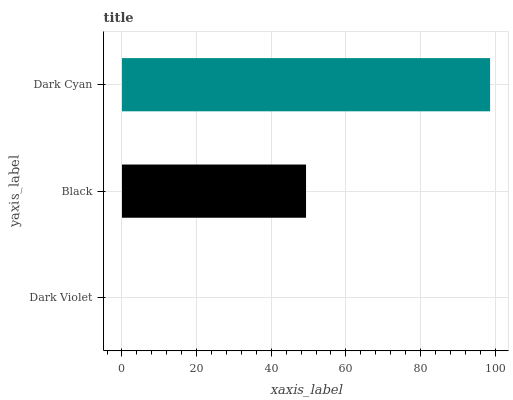Is Dark Violet the minimum?
Answer yes or no. Yes. Is Dark Cyan the maximum?
Answer yes or no. Yes. Is Black the minimum?
Answer yes or no. No. Is Black the maximum?
Answer yes or no. No. Is Black greater than Dark Violet?
Answer yes or no. Yes. Is Dark Violet less than Black?
Answer yes or no. Yes. Is Dark Violet greater than Black?
Answer yes or no. No. Is Black less than Dark Violet?
Answer yes or no. No. Is Black the high median?
Answer yes or no. Yes. Is Black the low median?
Answer yes or no. Yes. Is Dark Cyan the high median?
Answer yes or no. No. Is Dark Cyan the low median?
Answer yes or no. No. 